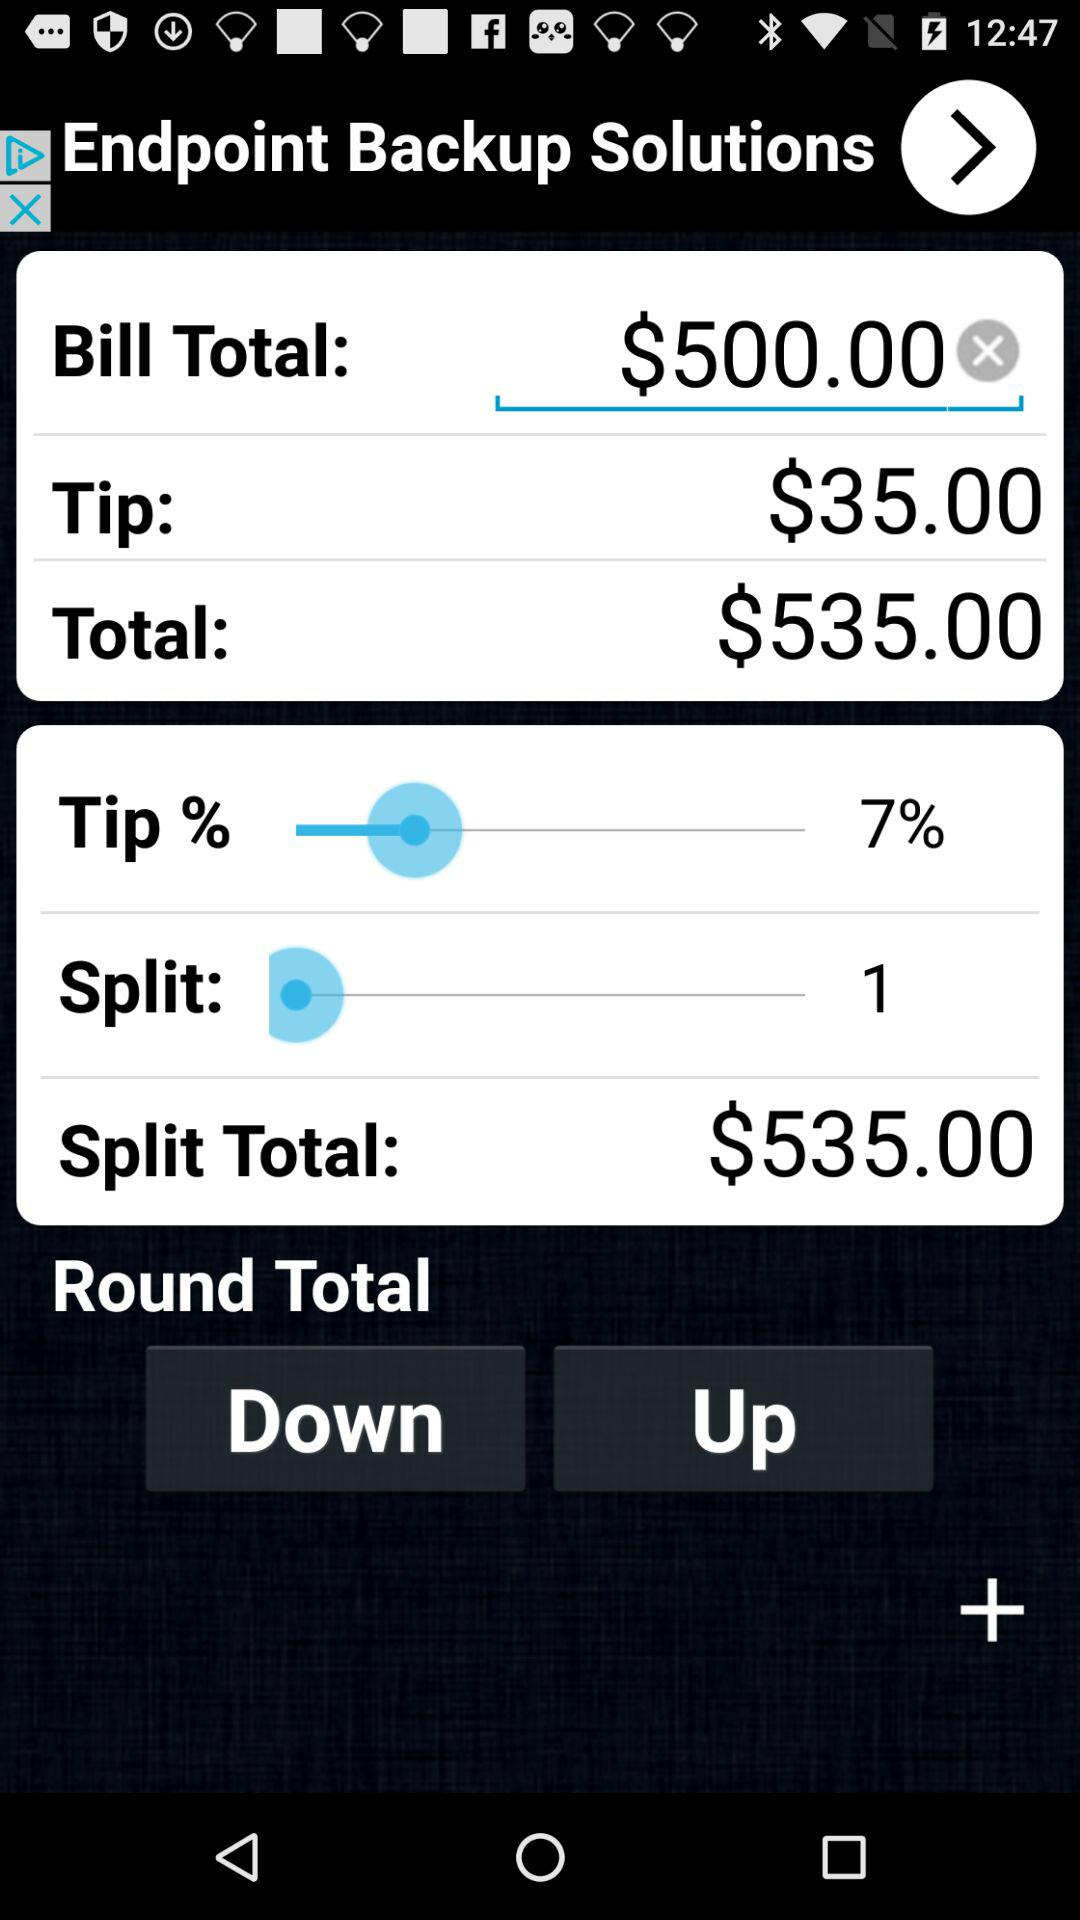How much will each person pay if the bill is split evenly?
Answer the question using a single word or phrase. $535.00 